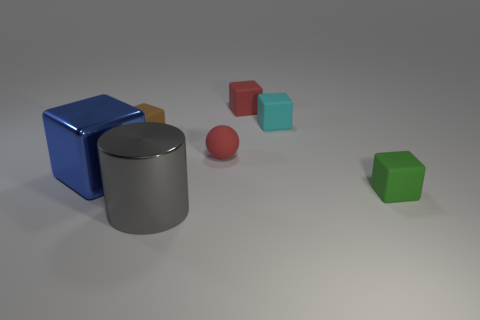Can you describe the shapes and their colors that you see in the image? Certainly! In the image, there are several geometric shapes. Starting from the left, there's a large blue cube and a brown matte cylinder. To the right of the cylinder, there is a smaller shiny red sphere, a small turquoise cube, a small red cube, and slightly further away is a smaller shiny green cube. 